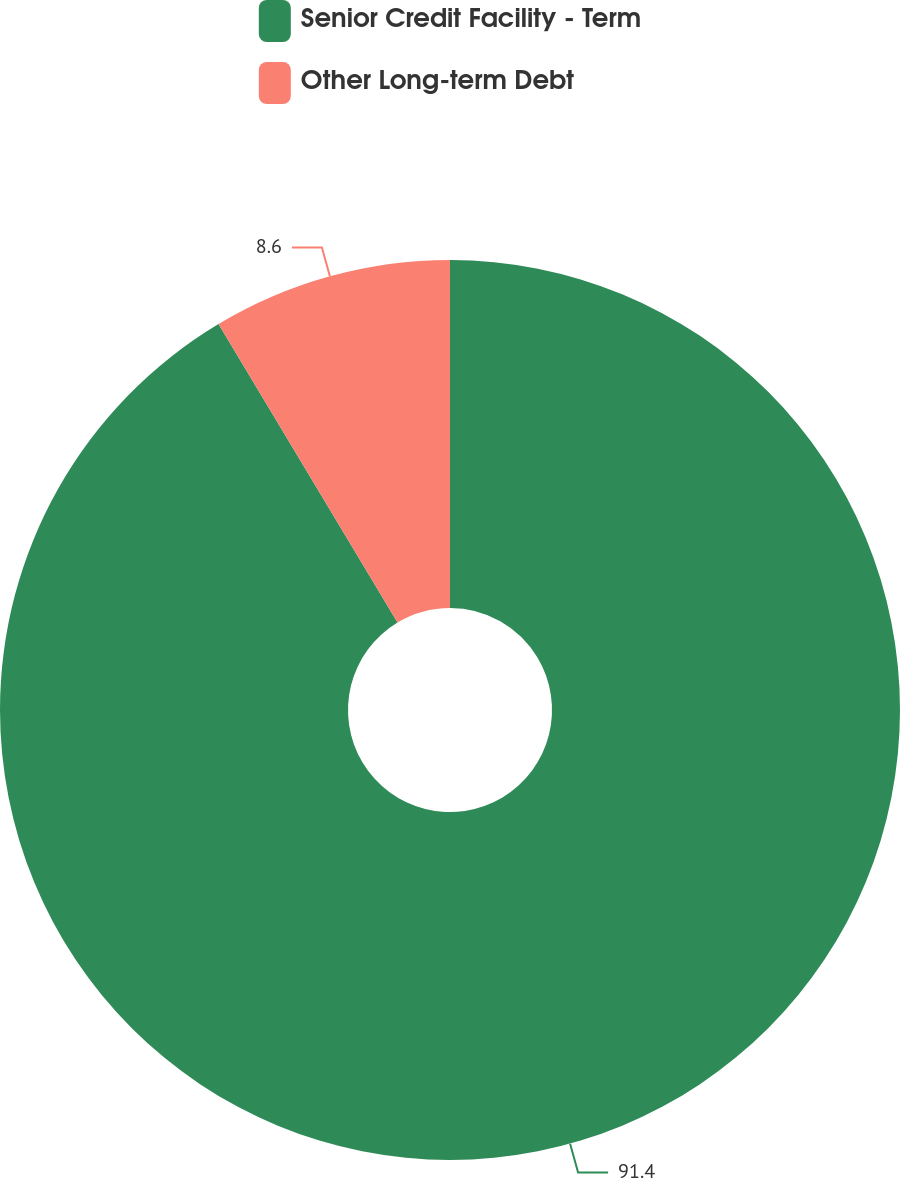<chart> <loc_0><loc_0><loc_500><loc_500><pie_chart><fcel>Senior Credit Facility - Term<fcel>Other Long-term Debt<nl><fcel>91.4%<fcel>8.6%<nl></chart> 